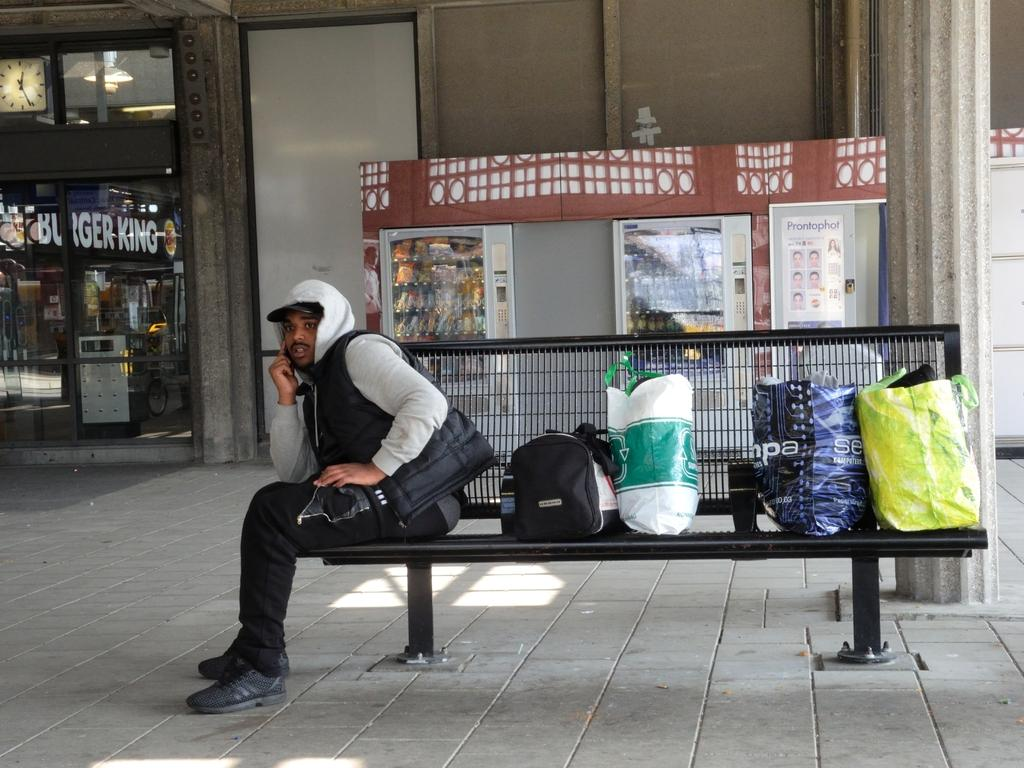What is the man in the image doing? The man is seated on a metal bench in the image. What else can be seen in the image besides the man? There are bags visible in the image. What type of structure is present in the image? There is a building in the image. What else can be found in the image? There are vending machines in the image. What type of meat is being cooked in the pan in the image? There is no pan or meat present in the image. Where is the lunchroom located in the image? The provided facts do not mention a lunchroom, so its location cannot be determined from the image. 